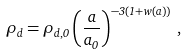<formula> <loc_0><loc_0><loc_500><loc_500>\rho _ { d } = \rho _ { d , 0 } \left ( \frac { a } { a _ { 0 } } \right ) ^ { - 3 ( 1 + w ( a ) ) } \, ,</formula> 